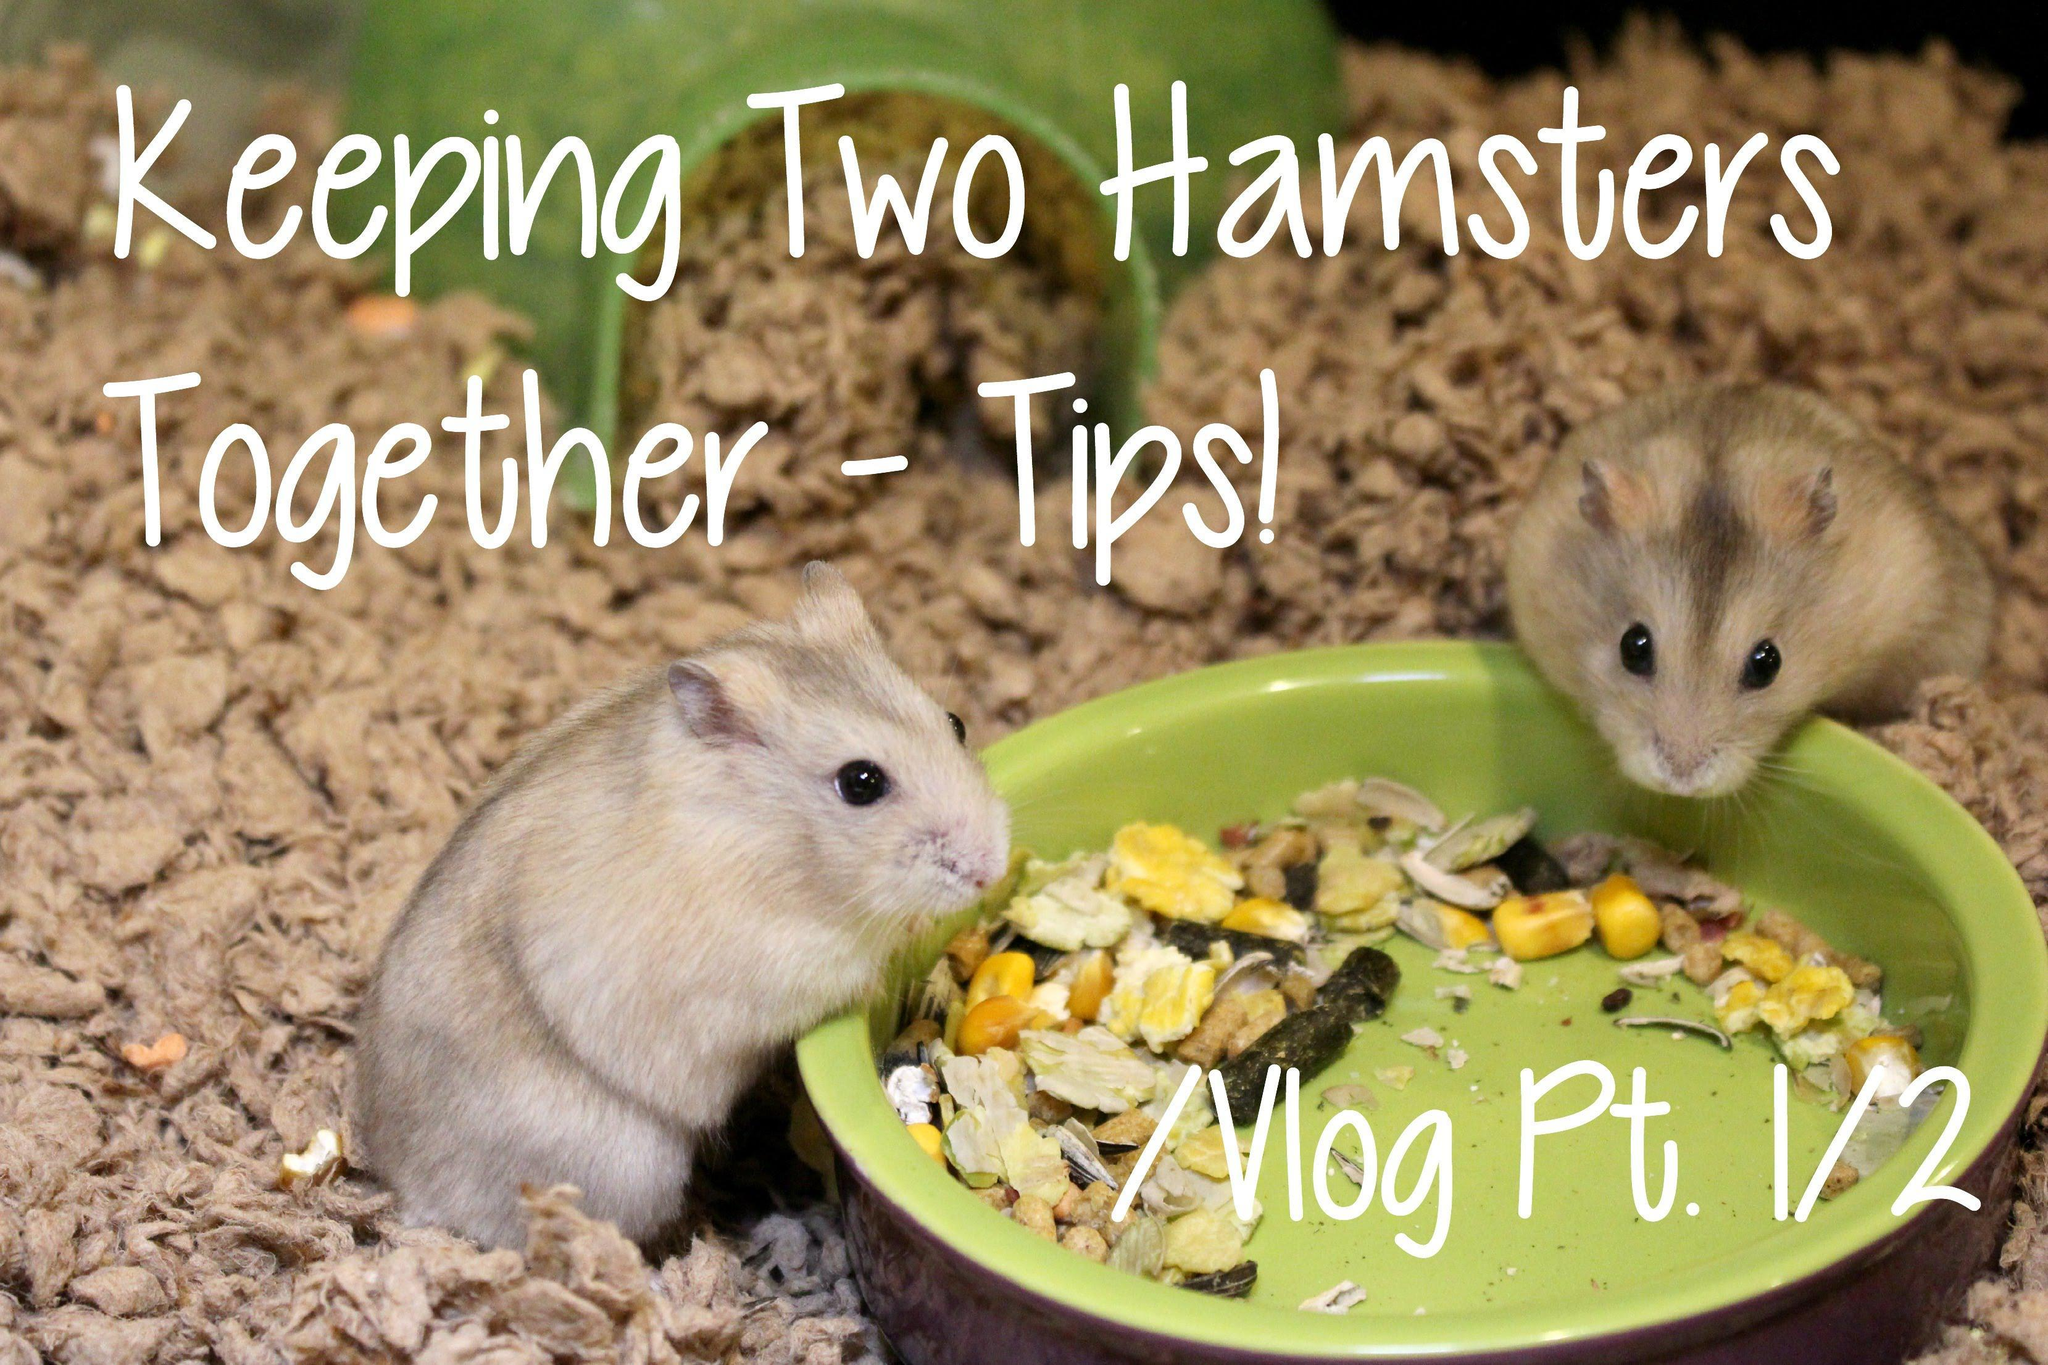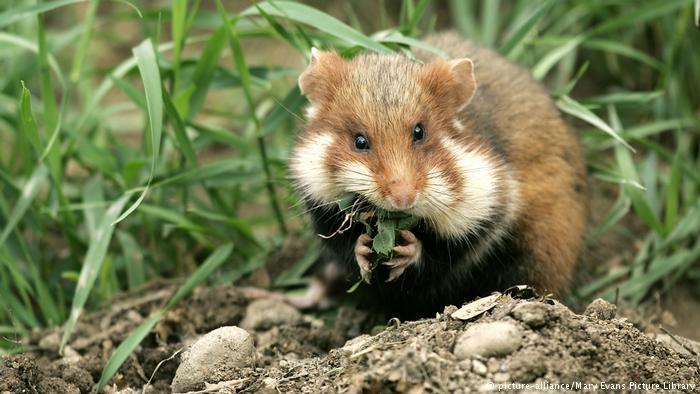The first image is the image on the left, the second image is the image on the right. Considering the images on both sides, is "The left image contains at least seven rodents." valid? Answer yes or no. No. The first image is the image on the left, the second image is the image on the right. Assess this claim about the two images: "At least one animal is outside.". Correct or not? Answer yes or no. Yes. 